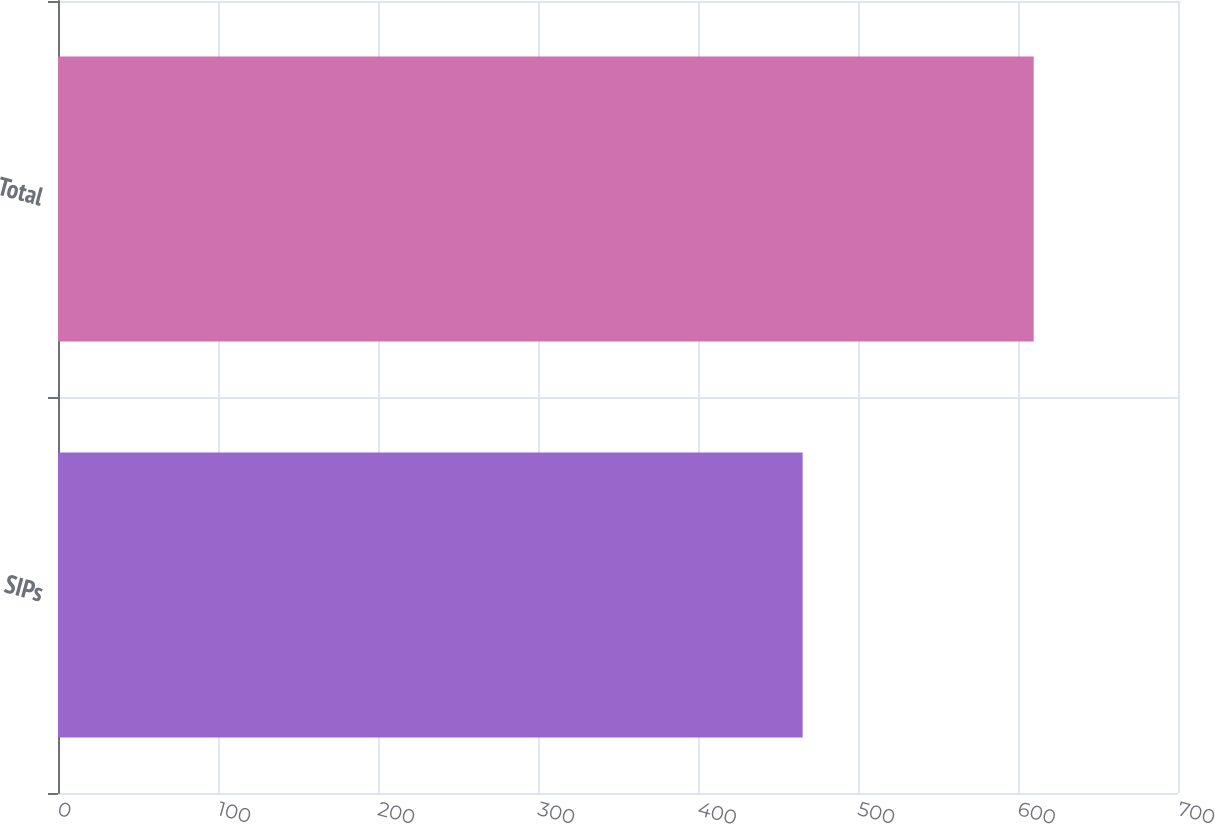Convert chart. <chart><loc_0><loc_0><loc_500><loc_500><bar_chart><fcel>SIPs<fcel>Total<nl><fcel>465.4<fcel>609.8<nl></chart> 